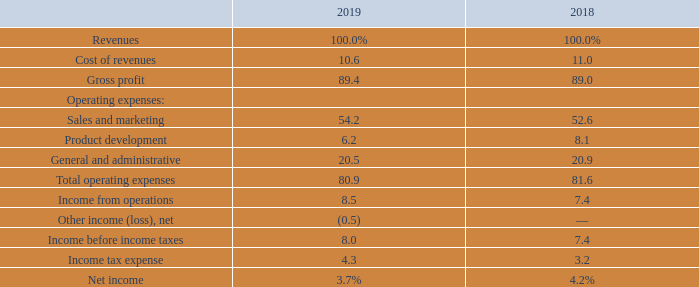Results of Operations
The following table sets forth, as a percentage of total revenues, the results from our operations for the periods indicated.
What is the gross profit for 2019 and 2018 respectively as a percentage of total revenues?
Answer scale should be: percent. 89.4, 89.0. What is the income from operations for 2019 and 2018 respectively as a percentage of total revenues?
Answer scale should be: percent. 8.5, 7.4. What is the cost of revenues for 2019 and 2018 respectively as a percentage of total revenues?
Answer scale should be: percent. 10.6, 11.0. What is the average cost of revenue for 2018 and 2019 as a percentage of total revenues?
Answer scale should be: percent. (10.6+11.0)/2
Answer: 10.8. What is the change in sales and marketing expenses between 2018 and 2019 as a percentage of total revenues?
Answer scale should be: percent. 54.2-52.6
Answer: 1.6. What is the average net income for 2018 and 2019 as a percentage of total revenues?
Answer scale should be: percent. (3.7+4.2)/2
Answer: 3.95. 